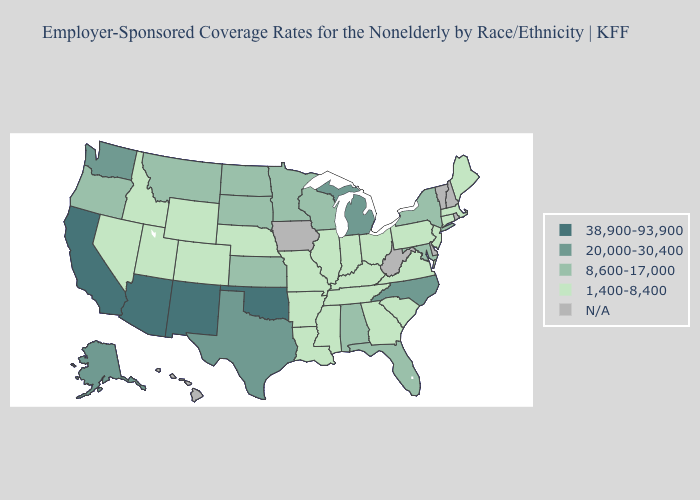What is the value of Indiana?
Give a very brief answer. 1,400-8,400. Name the states that have a value in the range 1,400-8,400?
Quick response, please. Arkansas, Colorado, Connecticut, Georgia, Idaho, Illinois, Indiana, Kentucky, Louisiana, Maine, Massachusetts, Mississippi, Missouri, Nebraska, Nevada, New Jersey, Ohio, Pennsylvania, South Carolina, Tennessee, Utah, Virginia, Wyoming. Does Texas have the lowest value in the South?
Short answer required. No. Which states hav the highest value in the West?
Answer briefly. Arizona, California, New Mexico. Is the legend a continuous bar?
Concise answer only. No. Name the states that have a value in the range N/A?
Short answer required. Delaware, Hawaii, Iowa, New Hampshire, Rhode Island, Vermont, West Virginia. Which states have the lowest value in the Northeast?
Be succinct. Connecticut, Maine, Massachusetts, New Jersey, Pennsylvania. Name the states that have a value in the range 1,400-8,400?
Concise answer only. Arkansas, Colorado, Connecticut, Georgia, Idaho, Illinois, Indiana, Kentucky, Louisiana, Maine, Massachusetts, Mississippi, Missouri, Nebraska, Nevada, New Jersey, Ohio, Pennsylvania, South Carolina, Tennessee, Utah, Virginia, Wyoming. Name the states that have a value in the range 38,900-93,900?
Short answer required. Arizona, California, New Mexico, Oklahoma. Which states have the lowest value in the USA?
Be succinct. Arkansas, Colorado, Connecticut, Georgia, Idaho, Illinois, Indiana, Kentucky, Louisiana, Maine, Massachusetts, Mississippi, Missouri, Nebraska, Nevada, New Jersey, Ohio, Pennsylvania, South Carolina, Tennessee, Utah, Virginia, Wyoming. Name the states that have a value in the range 20,000-30,400?
Short answer required. Alaska, Michigan, North Carolina, Texas, Washington. What is the highest value in states that border Pennsylvania?
Give a very brief answer. 8,600-17,000. 